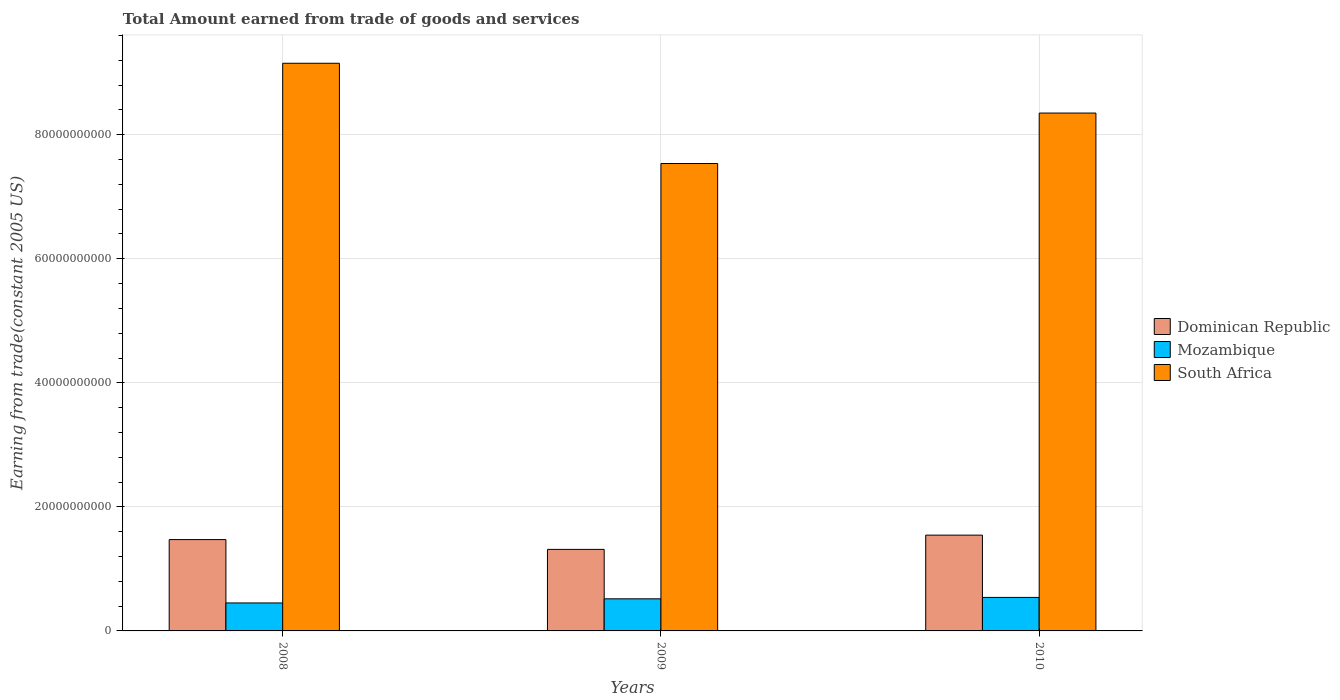How many different coloured bars are there?
Offer a very short reply. 3. What is the total amount earned by trading goods and services in Dominican Republic in 2010?
Keep it short and to the point. 1.54e+1. Across all years, what is the maximum total amount earned by trading goods and services in Dominican Republic?
Offer a terse response. 1.54e+1. Across all years, what is the minimum total amount earned by trading goods and services in South Africa?
Offer a very short reply. 7.54e+1. In which year was the total amount earned by trading goods and services in Mozambique maximum?
Ensure brevity in your answer.  2010. What is the total total amount earned by trading goods and services in South Africa in the graph?
Offer a very short reply. 2.50e+11. What is the difference between the total amount earned by trading goods and services in Dominican Republic in 2008 and that in 2010?
Keep it short and to the point. -7.19e+08. What is the difference between the total amount earned by trading goods and services in Dominican Republic in 2008 and the total amount earned by trading goods and services in South Africa in 2010?
Provide a short and direct response. -6.88e+1. What is the average total amount earned by trading goods and services in Mozambique per year?
Provide a succinct answer. 5.03e+09. In the year 2009, what is the difference between the total amount earned by trading goods and services in Mozambique and total amount earned by trading goods and services in South Africa?
Give a very brief answer. -7.02e+1. In how many years, is the total amount earned by trading goods and services in South Africa greater than 8000000000 US$?
Give a very brief answer. 3. What is the ratio of the total amount earned by trading goods and services in South Africa in 2008 to that in 2010?
Offer a terse response. 1.1. Is the difference between the total amount earned by trading goods and services in Mozambique in 2008 and 2010 greater than the difference between the total amount earned by trading goods and services in South Africa in 2008 and 2010?
Offer a terse response. No. What is the difference between the highest and the second highest total amount earned by trading goods and services in Dominican Republic?
Offer a very short reply. 7.19e+08. What is the difference between the highest and the lowest total amount earned by trading goods and services in Dominican Republic?
Offer a very short reply. 2.30e+09. What does the 1st bar from the left in 2009 represents?
Keep it short and to the point. Dominican Republic. What does the 3rd bar from the right in 2008 represents?
Your answer should be very brief. Dominican Republic. Is it the case that in every year, the sum of the total amount earned by trading goods and services in Mozambique and total amount earned by trading goods and services in Dominican Republic is greater than the total amount earned by trading goods and services in South Africa?
Keep it short and to the point. No. How many years are there in the graph?
Offer a terse response. 3. What is the difference between two consecutive major ticks on the Y-axis?
Provide a succinct answer. 2.00e+1. Does the graph contain any zero values?
Your answer should be compact. No. Does the graph contain grids?
Provide a short and direct response. Yes. Where does the legend appear in the graph?
Your response must be concise. Center right. How many legend labels are there?
Your answer should be very brief. 3. How are the legend labels stacked?
Provide a succinct answer. Vertical. What is the title of the graph?
Your response must be concise. Total Amount earned from trade of goods and services. Does "Kazakhstan" appear as one of the legend labels in the graph?
Provide a succinct answer. No. What is the label or title of the X-axis?
Ensure brevity in your answer.  Years. What is the label or title of the Y-axis?
Make the answer very short. Earning from trade(constant 2005 US). What is the Earning from trade(constant 2005 US) in Dominican Republic in 2008?
Offer a terse response. 1.47e+1. What is the Earning from trade(constant 2005 US) of Mozambique in 2008?
Provide a succinct answer. 4.51e+09. What is the Earning from trade(constant 2005 US) of South Africa in 2008?
Your response must be concise. 9.15e+1. What is the Earning from trade(constant 2005 US) in Dominican Republic in 2009?
Ensure brevity in your answer.  1.31e+1. What is the Earning from trade(constant 2005 US) of Mozambique in 2009?
Make the answer very short. 5.18e+09. What is the Earning from trade(constant 2005 US) in South Africa in 2009?
Ensure brevity in your answer.  7.54e+1. What is the Earning from trade(constant 2005 US) in Dominican Republic in 2010?
Make the answer very short. 1.54e+1. What is the Earning from trade(constant 2005 US) in Mozambique in 2010?
Your response must be concise. 5.40e+09. What is the Earning from trade(constant 2005 US) in South Africa in 2010?
Your response must be concise. 8.35e+1. Across all years, what is the maximum Earning from trade(constant 2005 US) in Dominican Republic?
Ensure brevity in your answer.  1.54e+1. Across all years, what is the maximum Earning from trade(constant 2005 US) in Mozambique?
Offer a terse response. 5.40e+09. Across all years, what is the maximum Earning from trade(constant 2005 US) of South Africa?
Give a very brief answer. 9.15e+1. Across all years, what is the minimum Earning from trade(constant 2005 US) in Dominican Republic?
Your answer should be compact. 1.31e+1. Across all years, what is the minimum Earning from trade(constant 2005 US) of Mozambique?
Provide a succinct answer. 4.51e+09. Across all years, what is the minimum Earning from trade(constant 2005 US) in South Africa?
Make the answer very short. 7.54e+1. What is the total Earning from trade(constant 2005 US) in Dominican Republic in the graph?
Ensure brevity in your answer.  4.33e+1. What is the total Earning from trade(constant 2005 US) of Mozambique in the graph?
Make the answer very short. 1.51e+1. What is the total Earning from trade(constant 2005 US) of South Africa in the graph?
Your response must be concise. 2.50e+11. What is the difference between the Earning from trade(constant 2005 US) in Dominican Republic in 2008 and that in 2009?
Give a very brief answer. 1.58e+09. What is the difference between the Earning from trade(constant 2005 US) of Mozambique in 2008 and that in 2009?
Ensure brevity in your answer.  -6.66e+08. What is the difference between the Earning from trade(constant 2005 US) in South Africa in 2008 and that in 2009?
Ensure brevity in your answer.  1.62e+1. What is the difference between the Earning from trade(constant 2005 US) in Dominican Republic in 2008 and that in 2010?
Provide a succinct answer. -7.19e+08. What is the difference between the Earning from trade(constant 2005 US) of Mozambique in 2008 and that in 2010?
Give a very brief answer. -8.92e+08. What is the difference between the Earning from trade(constant 2005 US) in South Africa in 2008 and that in 2010?
Keep it short and to the point. 8.03e+09. What is the difference between the Earning from trade(constant 2005 US) of Dominican Republic in 2009 and that in 2010?
Provide a short and direct response. -2.30e+09. What is the difference between the Earning from trade(constant 2005 US) in Mozambique in 2009 and that in 2010?
Your answer should be very brief. -2.26e+08. What is the difference between the Earning from trade(constant 2005 US) in South Africa in 2009 and that in 2010?
Your response must be concise. -8.13e+09. What is the difference between the Earning from trade(constant 2005 US) in Dominican Republic in 2008 and the Earning from trade(constant 2005 US) in Mozambique in 2009?
Offer a terse response. 9.55e+09. What is the difference between the Earning from trade(constant 2005 US) in Dominican Republic in 2008 and the Earning from trade(constant 2005 US) in South Africa in 2009?
Ensure brevity in your answer.  -6.06e+1. What is the difference between the Earning from trade(constant 2005 US) of Mozambique in 2008 and the Earning from trade(constant 2005 US) of South Africa in 2009?
Make the answer very short. -7.09e+1. What is the difference between the Earning from trade(constant 2005 US) in Dominican Republic in 2008 and the Earning from trade(constant 2005 US) in Mozambique in 2010?
Offer a very short reply. 9.32e+09. What is the difference between the Earning from trade(constant 2005 US) of Dominican Republic in 2008 and the Earning from trade(constant 2005 US) of South Africa in 2010?
Offer a very short reply. -6.88e+1. What is the difference between the Earning from trade(constant 2005 US) in Mozambique in 2008 and the Earning from trade(constant 2005 US) in South Africa in 2010?
Give a very brief answer. -7.90e+1. What is the difference between the Earning from trade(constant 2005 US) in Dominican Republic in 2009 and the Earning from trade(constant 2005 US) in Mozambique in 2010?
Your answer should be very brief. 7.74e+09. What is the difference between the Earning from trade(constant 2005 US) in Dominican Republic in 2009 and the Earning from trade(constant 2005 US) in South Africa in 2010?
Keep it short and to the point. -7.04e+1. What is the difference between the Earning from trade(constant 2005 US) in Mozambique in 2009 and the Earning from trade(constant 2005 US) in South Africa in 2010?
Keep it short and to the point. -7.83e+1. What is the average Earning from trade(constant 2005 US) of Dominican Republic per year?
Offer a very short reply. 1.44e+1. What is the average Earning from trade(constant 2005 US) of Mozambique per year?
Provide a succinct answer. 5.03e+09. What is the average Earning from trade(constant 2005 US) in South Africa per year?
Your response must be concise. 8.35e+1. In the year 2008, what is the difference between the Earning from trade(constant 2005 US) of Dominican Republic and Earning from trade(constant 2005 US) of Mozambique?
Provide a succinct answer. 1.02e+1. In the year 2008, what is the difference between the Earning from trade(constant 2005 US) of Dominican Republic and Earning from trade(constant 2005 US) of South Africa?
Keep it short and to the point. -7.68e+1. In the year 2008, what is the difference between the Earning from trade(constant 2005 US) of Mozambique and Earning from trade(constant 2005 US) of South Africa?
Ensure brevity in your answer.  -8.70e+1. In the year 2009, what is the difference between the Earning from trade(constant 2005 US) in Dominican Republic and Earning from trade(constant 2005 US) in Mozambique?
Provide a succinct answer. 7.97e+09. In the year 2009, what is the difference between the Earning from trade(constant 2005 US) in Dominican Republic and Earning from trade(constant 2005 US) in South Africa?
Ensure brevity in your answer.  -6.22e+1. In the year 2009, what is the difference between the Earning from trade(constant 2005 US) of Mozambique and Earning from trade(constant 2005 US) of South Africa?
Keep it short and to the point. -7.02e+1. In the year 2010, what is the difference between the Earning from trade(constant 2005 US) of Dominican Republic and Earning from trade(constant 2005 US) of Mozambique?
Your response must be concise. 1.00e+1. In the year 2010, what is the difference between the Earning from trade(constant 2005 US) in Dominican Republic and Earning from trade(constant 2005 US) in South Africa?
Give a very brief answer. -6.81e+1. In the year 2010, what is the difference between the Earning from trade(constant 2005 US) in Mozambique and Earning from trade(constant 2005 US) in South Africa?
Keep it short and to the point. -7.81e+1. What is the ratio of the Earning from trade(constant 2005 US) of Dominican Republic in 2008 to that in 2009?
Offer a very short reply. 1.12. What is the ratio of the Earning from trade(constant 2005 US) in Mozambique in 2008 to that in 2009?
Your answer should be compact. 0.87. What is the ratio of the Earning from trade(constant 2005 US) in South Africa in 2008 to that in 2009?
Your answer should be compact. 1.21. What is the ratio of the Earning from trade(constant 2005 US) of Dominican Republic in 2008 to that in 2010?
Your response must be concise. 0.95. What is the ratio of the Earning from trade(constant 2005 US) of Mozambique in 2008 to that in 2010?
Your answer should be very brief. 0.83. What is the ratio of the Earning from trade(constant 2005 US) of South Africa in 2008 to that in 2010?
Your answer should be very brief. 1.1. What is the ratio of the Earning from trade(constant 2005 US) of Dominican Republic in 2009 to that in 2010?
Provide a succinct answer. 0.85. What is the ratio of the Earning from trade(constant 2005 US) of Mozambique in 2009 to that in 2010?
Your answer should be very brief. 0.96. What is the ratio of the Earning from trade(constant 2005 US) of South Africa in 2009 to that in 2010?
Make the answer very short. 0.9. What is the difference between the highest and the second highest Earning from trade(constant 2005 US) in Dominican Republic?
Offer a very short reply. 7.19e+08. What is the difference between the highest and the second highest Earning from trade(constant 2005 US) of Mozambique?
Offer a very short reply. 2.26e+08. What is the difference between the highest and the second highest Earning from trade(constant 2005 US) in South Africa?
Your response must be concise. 8.03e+09. What is the difference between the highest and the lowest Earning from trade(constant 2005 US) of Dominican Republic?
Give a very brief answer. 2.30e+09. What is the difference between the highest and the lowest Earning from trade(constant 2005 US) of Mozambique?
Provide a succinct answer. 8.92e+08. What is the difference between the highest and the lowest Earning from trade(constant 2005 US) of South Africa?
Ensure brevity in your answer.  1.62e+1. 